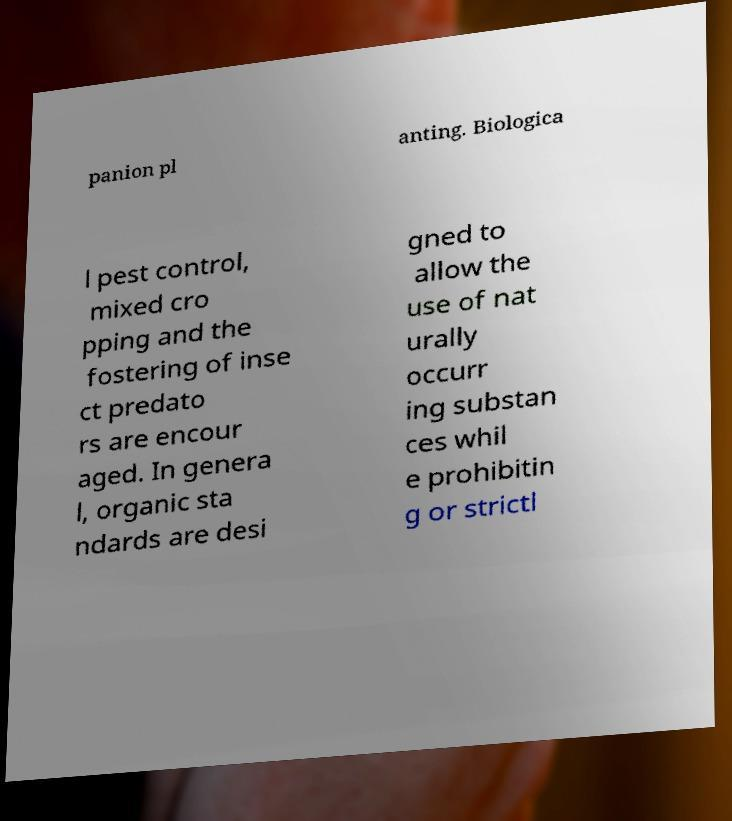Could you extract and type out the text from this image? panion pl anting. Biologica l pest control, mixed cro pping and the fostering of inse ct predato rs are encour aged. In genera l, organic sta ndards are desi gned to allow the use of nat urally occurr ing substan ces whil e prohibitin g or strictl 